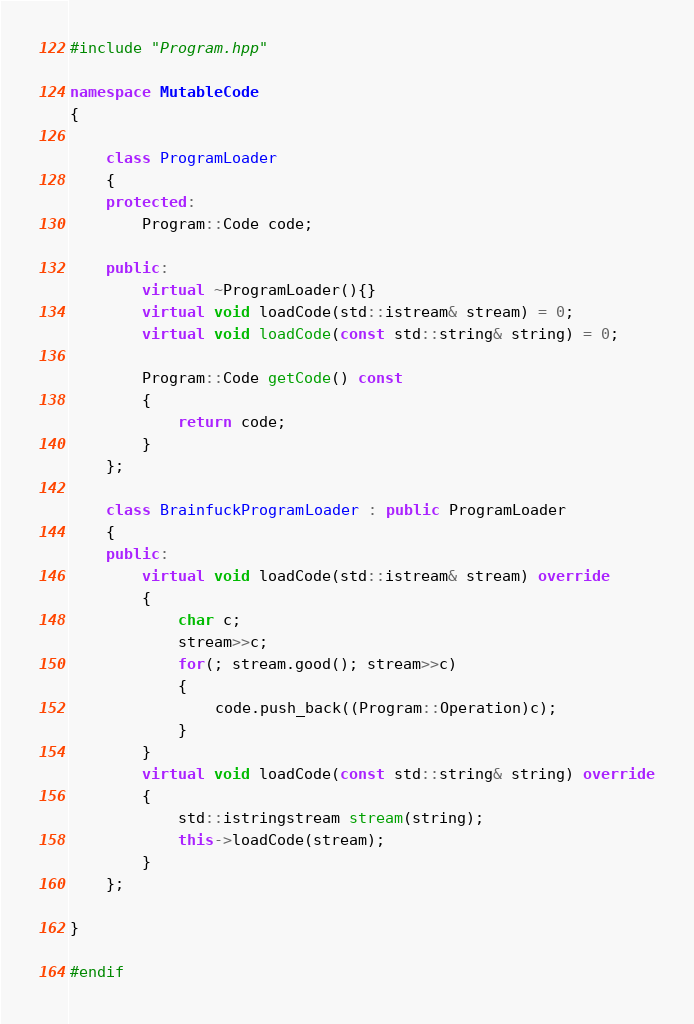<code> <loc_0><loc_0><loc_500><loc_500><_C++_>#include "Program.hpp"

namespace MutableCode
{

	class ProgramLoader
	{
	protected:
		Program::Code code;

	public:
		virtual ~ProgramLoader(){}
		virtual void loadCode(std::istream& stream) = 0;
		virtual void loadCode(const std::string& string) = 0;

		Program::Code getCode() const
		{
			return code;
		}
	};

	class BrainfuckProgramLoader : public ProgramLoader
	{
	public:
		virtual void loadCode(std::istream& stream) override
		{
			char c;
			stream>>c;
			for(; stream.good(); stream>>c)
			{
				code.push_back((Program::Operation)c);
			}
		}
		virtual void loadCode(const std::string& string) override
		{
			std::istringstream stream(string);
			this->loadCode(stream);
		}
	};

}

#endif
</code> 